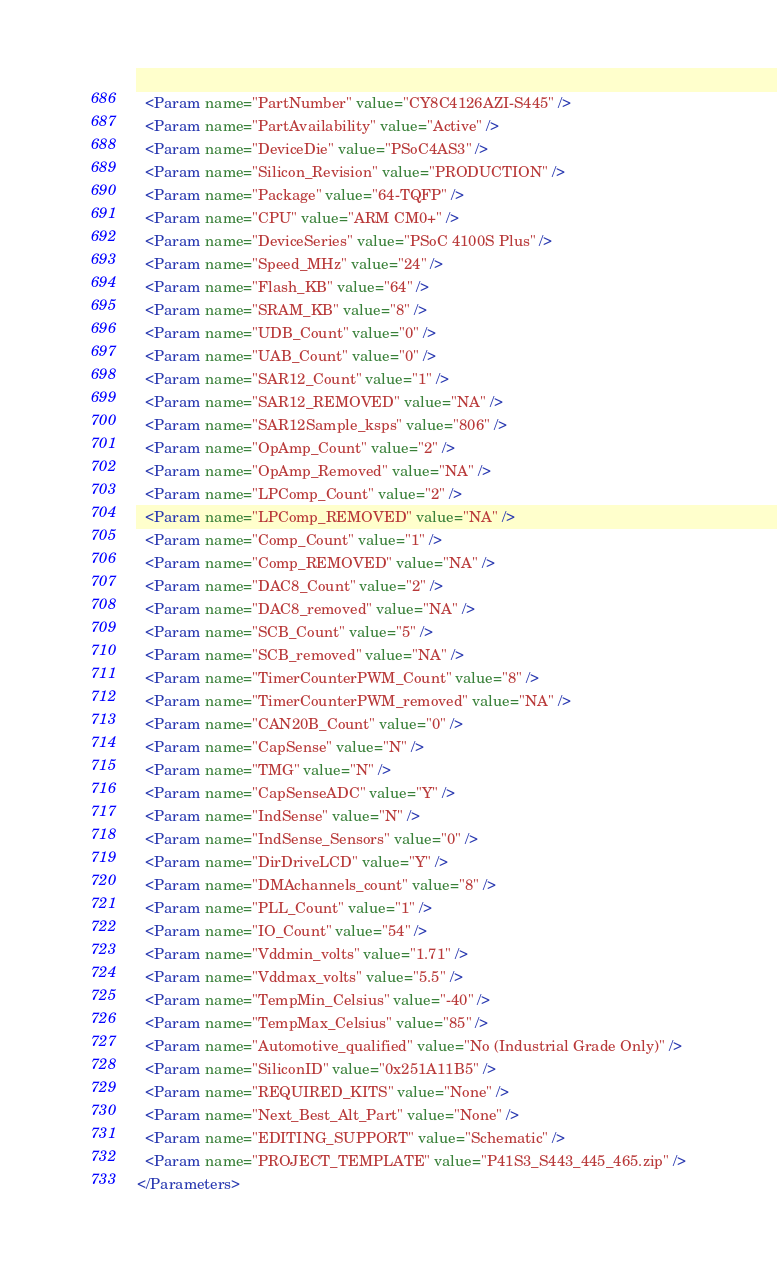Convert code to text. <code><loc_0><loc_0><loc_500><loc_500><_XML_>  <Param name="PartNumber" value="CY8C4126AZI-S445" />
  <Param name="PartAvailability" value="Active" />
  <Param name="DeviceDie" value="PSoC4AS3" />
  <Param name="Silicon_Revision" value="PRODUCTION" />
  <Param name="Package" value="64-TQFP" />
  <Param name="CPU" value="ARM CM0+" />
  <Param name="DeviceSeries" value="PSoC 4100S Plus" />
  <Param name="Speed_MHz" value="24" />
  <Param name="Flash_KB" value="64" />
  <Param name="SRAM_KB" value="8" />
  <Param name="UDB_Count" value="0" />
  <Param name="UAB_Count" value="0" />
  <Param name="SAR12_Count" value="1" />
  <Param name="SAR12_REMOVED" value="NA" />
  <Param name="SAR12Sample_ksps" value="806" />
  <Param name="OpAmp_Count" value="2" />
  <Param name="OpAmp_Removed" value="NA" />
  <Param name="LPComp_Count" value="2" />
  <Param name="LPComp_REMOVED" value="NA" />
  <Param name="Comp_Count" value="1" />
  <Param name="Comp_REMOVED" value="NA" />
  <Param name="DAC8_Count" value="2" />
  <Param name="DAC8_removed" value="NA" />
  <Param name="SCB_Count" value="5" />
  <Param name="SCB_removed" value="NA" />
  <Param name="TimerCounterPWM_Count" value="8" />
  <Param name="TimerCounterPWM_removed" value="NA" />
  <Param name="CAN20B_Count" value="0" />
  <Param name="CapSense" value="N" />
  <Param name="TMG" value="N" />
  <Param name="CapSenseADC" value="Y" />
  <Param name="IndSense" value="N" />
  <Param name="IndSense_Sensors" value="0" />
  <Param name="DirDriveLCD" value="Y" />
  <Param name="DMAchannels_count" value="8" />
  <Param name="PLL_Count" value="1" />
  <Param name="IO_Count" value="54" />
  <Param name="Vddmin_volts" value="1.71" />
  <Param name="Vddmax_volts" value="5.5" />
  <Param name="TempMin_Celsius" value="-40" />
  <Param name="TempMax_Celsius" value="85" />
  <Param name="Automotive_qualified" value="No (Industrial Grade Only)" />
  <Param name="SiliconID" value="0x251A11B5" />
  <Param name="REQUIRED_KITS" value="None" />
  <Param name="Next_Best_Alt_Part" value="None" />
  <Param name="EDITING_SUPPORT" value="Schematic" />
  <Param name="PROJECT_TEMPLATE" value="P41S3_S443_445_465.zip" />
</Parameters></code> 